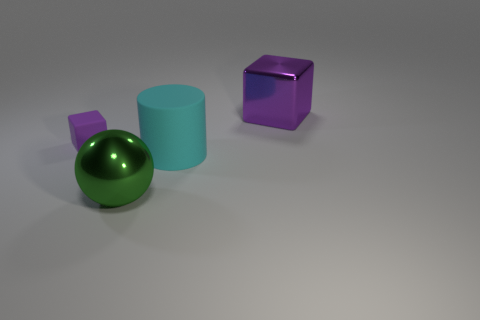Is there anything else that is the same shape as the green metallic thing?
Ensure brevity in your answer.  No. There is another purple metal thing that is the same shape as the small object; what is its size?
Keep it short and to the point. Large. Is there any other thing that has the same size as the matte block?
Your answer should be very brief. No. What material is the purple cube that is to the left of the cube that is right of the large rubber object?
Offer a very short reply. Rubber. Does the cyan thing have the same shape as the small purple object?
Make the answer very short. No. What number of purple things are both right of the purple matte block and on the left side of the metal cube?
Make the answer very short. 0. Are there an equal number of small cubes on the right side of the large green shiny ball and big cubes that are on the left side of the metal block?
Make the answer very short. Yes. There is a block left of the big green metallic thing; is its size the same as the metal object that is to the left of the big cyan object?
Provide a short and direct response. No. There is a object that is left of the large matte object and in front of the matte cube; what material is it made of?
Your answer should be compact. Metal. Are there fewer yellow shiny objects than big things?
Make the answer very short. Yes. 